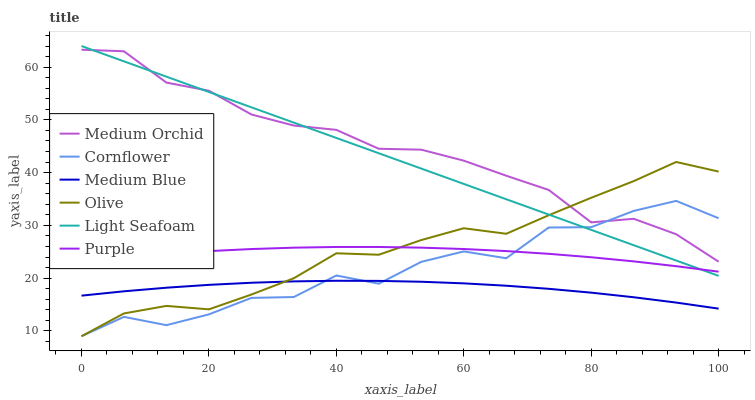Does Purple have the minimum area under the curve?
Answer yes or no. No. Does Purple have the maximum area under the curve?
Answer yes or no. No. Is Purple the smoothest?
Answer yes or no. No. Is Purple the roughest?
Answer yes or no. No. Does Purple have the lowest value?
Answer yes or no. No. Does Purple have the highest value?
Answer yes or no. No. Is Medium Blue less than Purple?
Answer yes or no. Yes. Is Medium Orchid greater than Medium Blue?
Answer yes or no. Yes. Does Medium Blue intersect Purple?
Answer yes or no. No. 